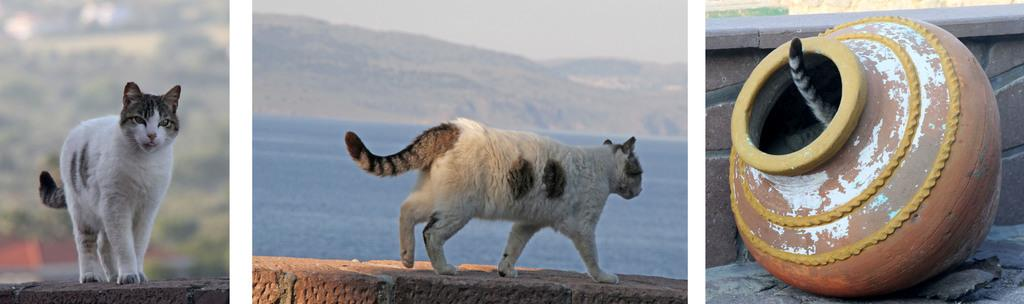What is the main feature of the image? The image contains a collage of pictures. Can you describe any specific elements within the collage? Yes, there is a cat on the surface in one of the pictures, and there is a vessel placed on the ground in another picture. What can be seen in the background of the image? Water, a hill, and the sky are visible in the background of the image. Where is the coat hanging in the image? There is no coat present in the image. What type of wrench is being used to fix the cat in the image? There is no wrench or any repair work involving the cat in the image. 